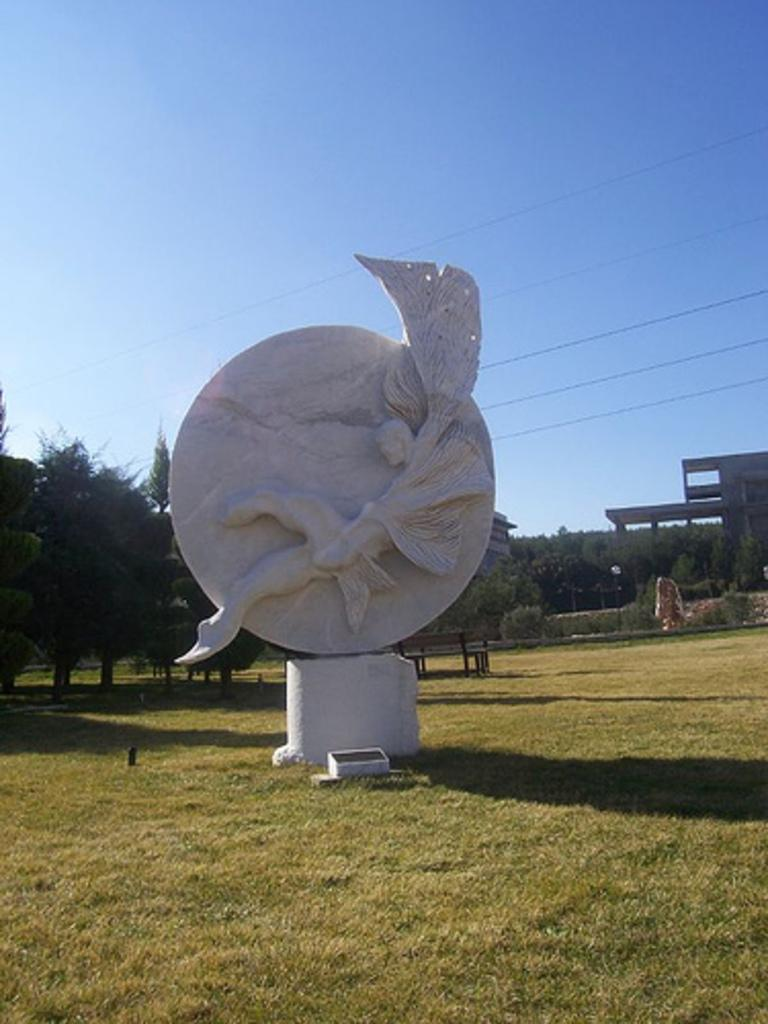What is the main object on the ground in the image? There is a white color object on the ground in the image. What type of natural environment can be seen in the background of the image? There is grass, trees, and the sky visible in the background of the image. What type of man-made structures are present in the background of the image? There are wires and a building visible in the background of the image. Are there any other objects or features in the background of the image? Yes, there are other objects in the background of the image. What type of cap can be seen on the coast in the image? There is no cap or coast present in the image. Is there a park visible in the image? There is no park mentioned or visible in the image. 